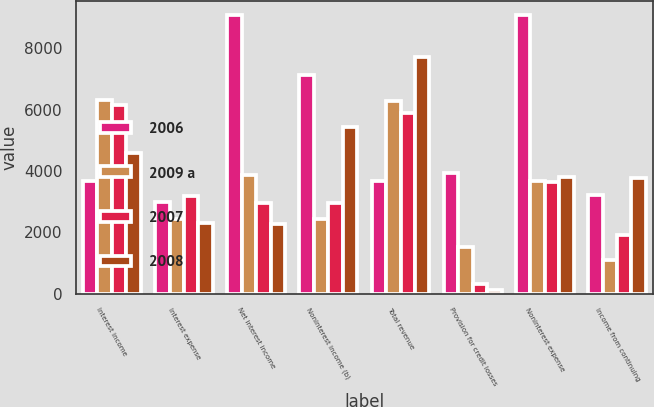Convert chart to OTSL. <chart><loc_0><loc_0><loc_500><loc_500><stacked_bar_chart><ecel><fcel>Interest income<fcel>Interest expense<fcel>Net interest income<fcel>Noninterest income (b)<fcel>Total revenue<fcel>Provision for credit losses<fcel>Noninterest expense<fcel>Income from continuing<nl><fcel>2006<fcel>3668.5<fcel>3003<fcel>9083<fcel>7145<fcel>3668.5<fcel>3930<fcel>9073<fcel>3225<nl><fcel>2009 a<fcel>6301<fcel>2447<fcel>3854<fcel>2442<fcel>6296<fcel>1517<fcel>3685<fcel>1094<nl><fcel>2007<fcel>6144<fcel>3197<fcel>2947<fcel>2944<fcel>5891<fcel>315<fcel>3652<fcel>1924<nl><fcel>2008<fcel>4592<fcel>2309<fcel>2283<fcel>5422<fcel>7705<fcel>124<fcel>3795<fcel>3786<nl></chart> 